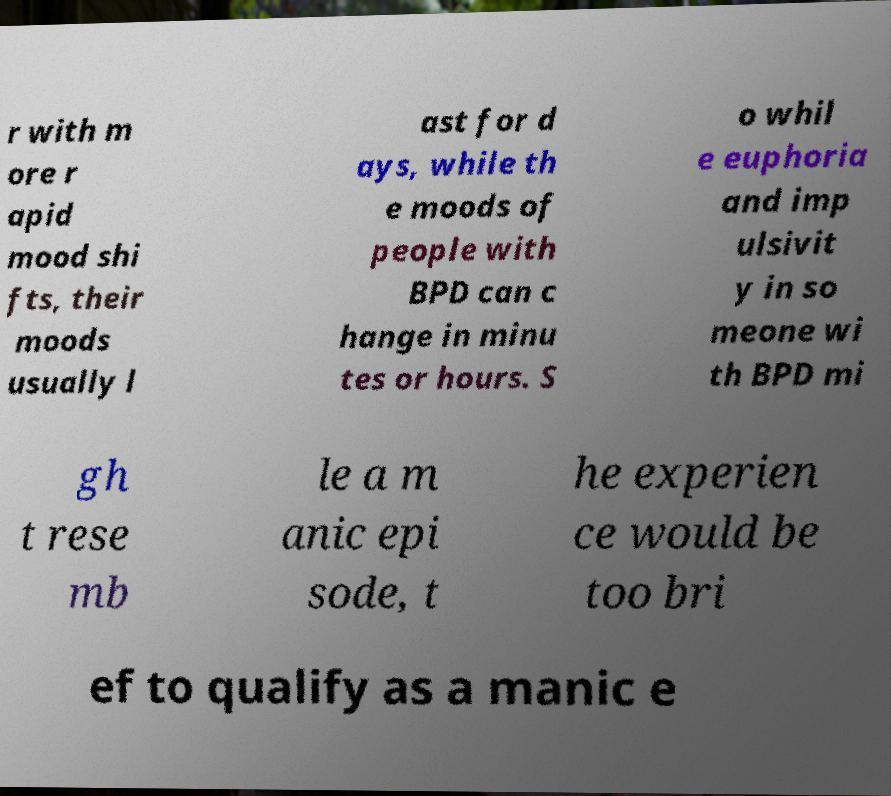There's text embedded in this image that I need extracted. Can you transcribe it verbatim? r with m ore r apid mood shi fts, their moods usually l ast for d ays, while th e moods of people with BPD can c hange in minu tes or hours. S o whil e euphoria and imp ulsivit y in so meone wi th BPD mi gh t rese mb le a m anic epi sode, t he experien ce would be too bri ef to qualify as a manic e 